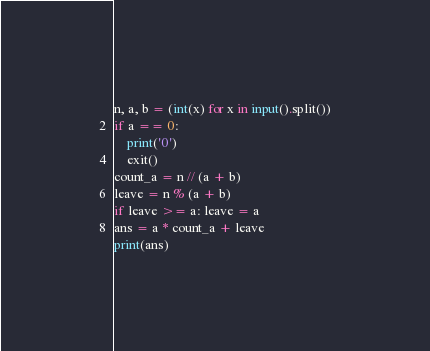Convert code to text. <code><loc_0><loc_0><loc_500><loc_500><_Python_>n, a, b = (int(x) for x in input().split())
if a == 0:
    print('0')
    exit()
count_a = n // (a + b)
leave = n % (a + b)
if leave >= a: leave = a
ans = a * count_a + leave
print(ans)</code> 